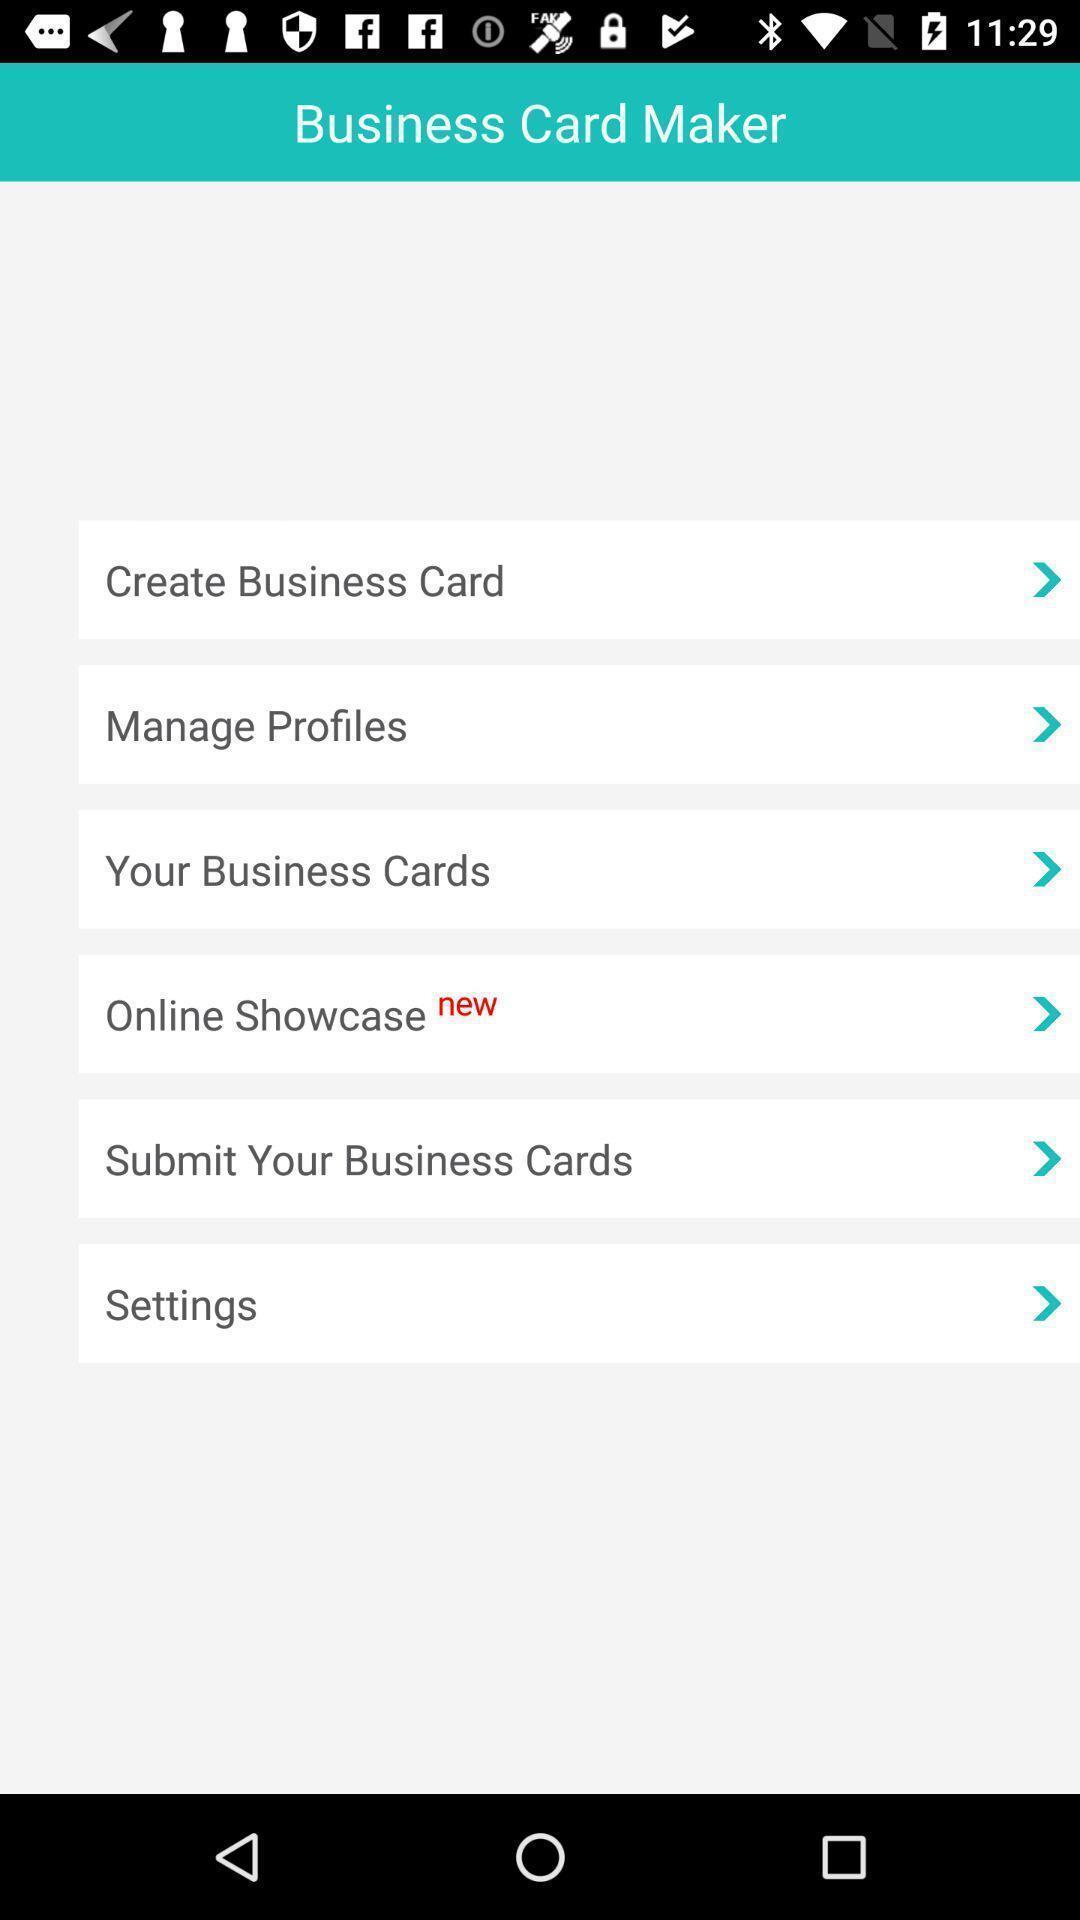What is the overall content of this screenshot? Page displaying the various options. 